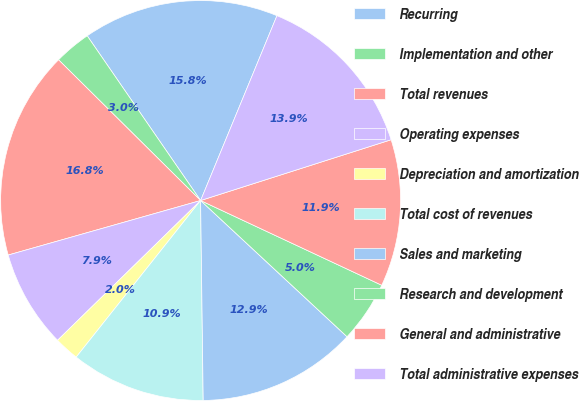Convert chart to OTSL. <chart><loc_0><loc_0><loc_500><loc_500><pie_chart><fcel>Recurring<fcel>Implementation and other<fcel>Total revenues<fcel>Operating expenses<fcel>Depreciation and amortization<fcel>Total cost of revenues<fcel>Sales and marketing<fcel>Research and development<fcel>General and administrative<fcel>Total administrative expenses<nl><fcel>15.83%<fcel>2.98%<fcel>16.82%<fcel>7.92%<fcel>2.0%<fcel>10.89%<fcel>12.87%<fcel>4.96%<fcel>11.88%<fcel>13.85%<nl></chart> 